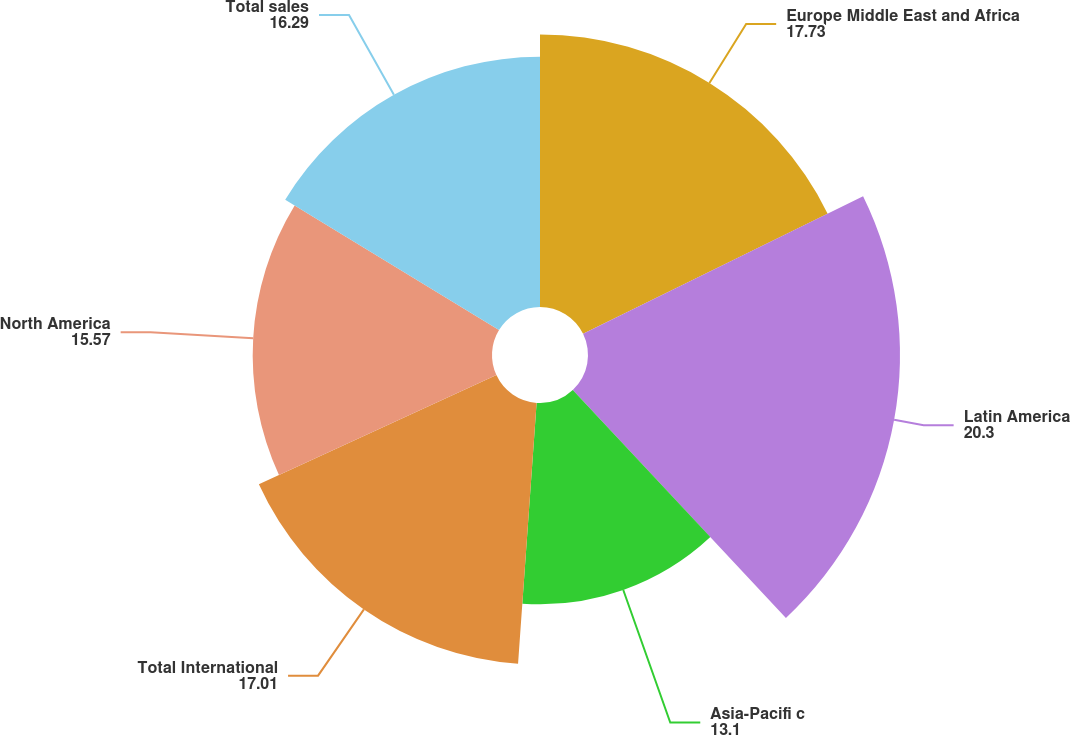<chart> <loc_0><loc_0><loc_500><loc_500><pie_chart><fcel>Europe Middle East and Africa<fcel>Latin America<fcel>Asia-Pacifi c<fcel>Total International<fcel>North America<fcel>Total sales<nl><fcel>17.73%<fcel>20.3%<fcel>13.1%<fcel>17.01%<fcel>15.57%<fcel>16.29%<nl></chart> 